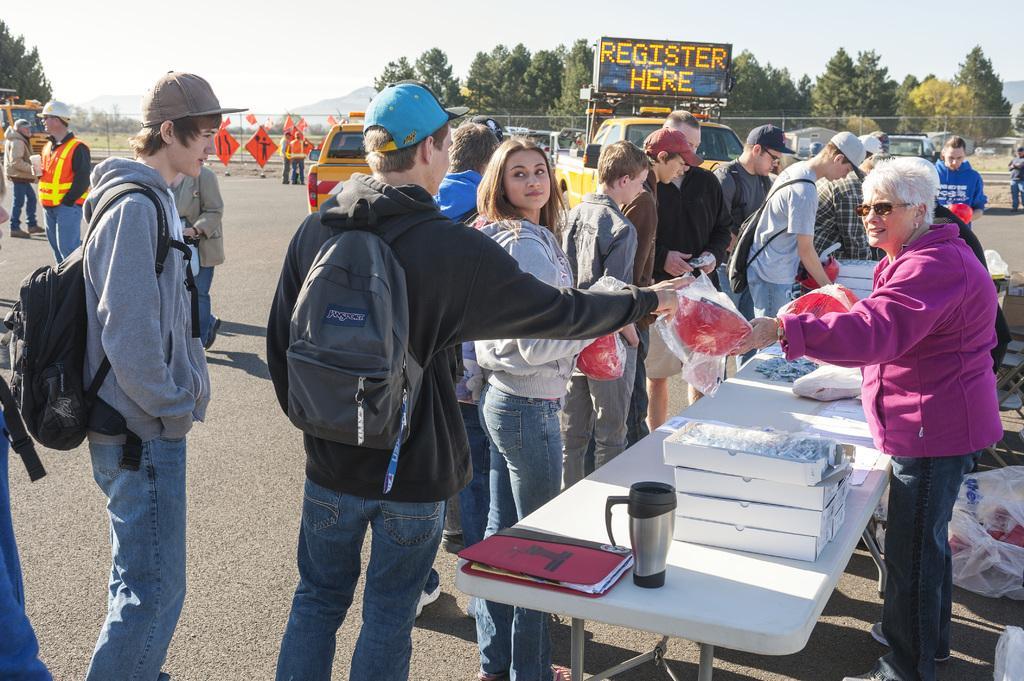Can you describe this image briefly? This is a picture taken in the outdoors. It is sunny. There are group of people standing on the floor and a woman in pink jacket was distributing some items. In front of the people there is a table on the table there are file, jar and boxes. Behind the people cars are parked on a road, trees and sky. 